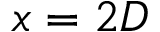<formula> <loc_0><loc_0><loc_500><loc_500>x = 2 D</formula> 